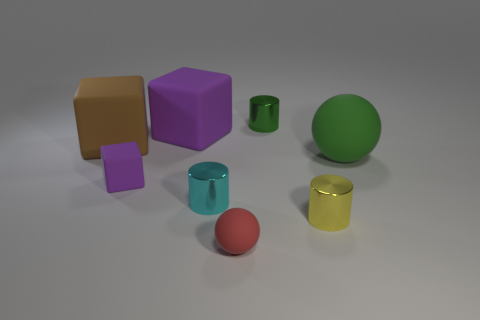Add 1 metal things. How many objects exist? 9 Subtract all spheres. How many objects are left? 6 Subtract all tiny matte blocks. Subtract all small purple matte blocks. How many objects are left? 6 Add 8 large green matte balls. How many large green matte balls are left? 9 Add 4 cyan cylinders. How many cyan cylinders exist? 5 Subtract 0 purple spheres. How many objects are left? 8 